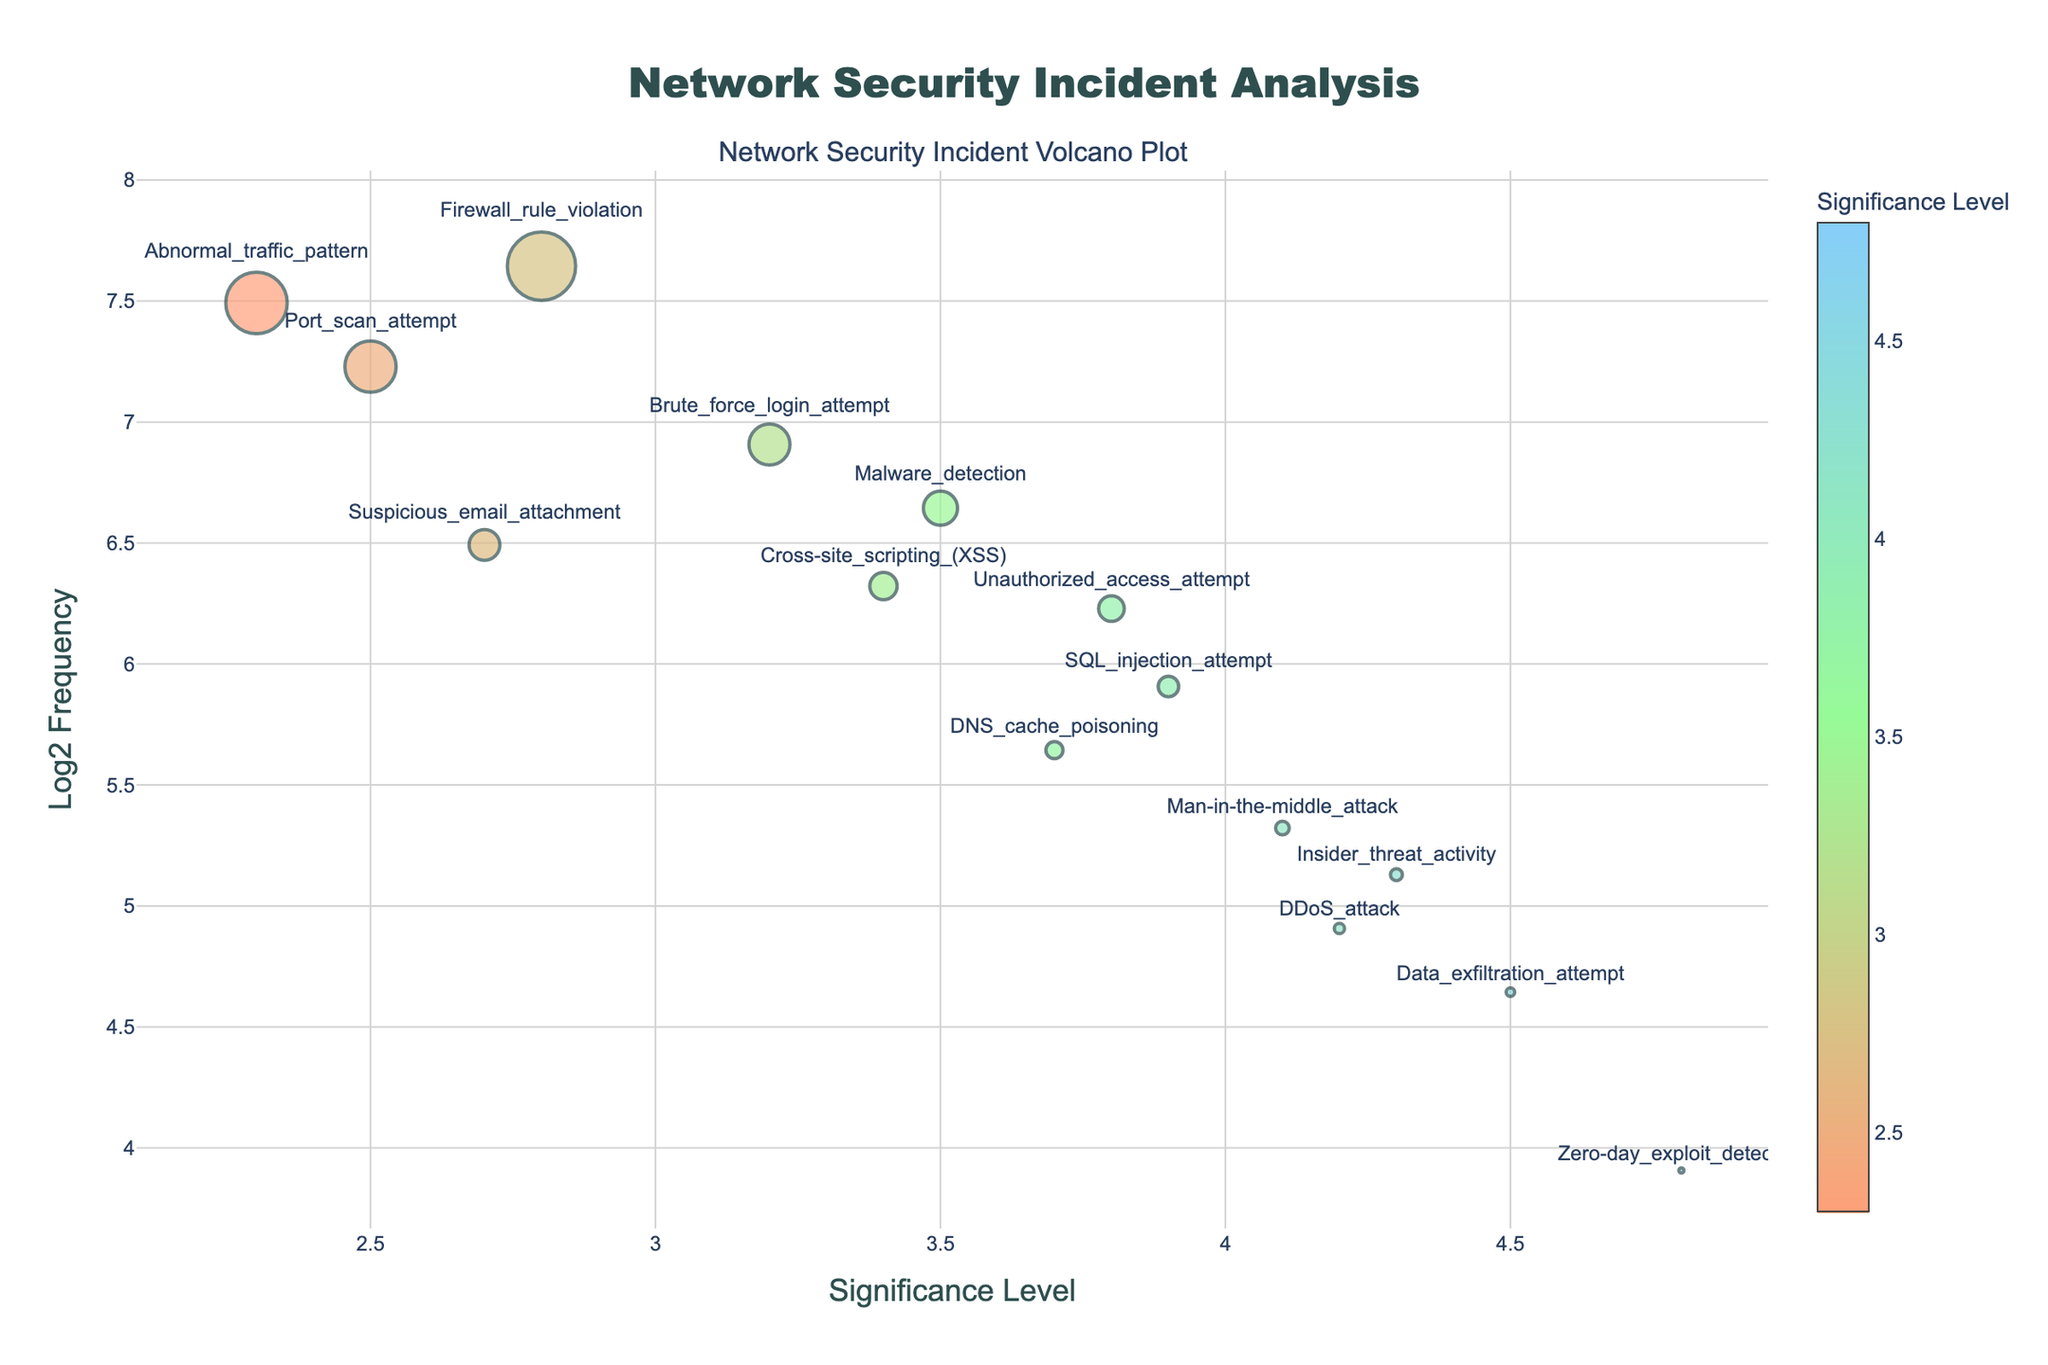what is the title of the plot? The title is the text at the very top of the figure that usually describes what the figure is about. Looking at the figure, the title reads "Network Security Incident Analysis".
Answer: Network Security Incident Analysis what is the y-axis representing? The y-axis title is usually positioned alongside the vertical axis and describes what is being measured. In the figure, the y-axis title is "Log2 Frequency".
Answer: Log2 Frequency Which event has the highest significance level? To find the event with the highest significance level, look for the highest point on the x-axis. The event corresponding to this point in the figure is labeled "Zero-day_exploit_detection".
Answer: Zero-day_exploit_detection How many incidents have a significance level above 4? We look for all data points located to the right of the x-axis value of 4. Those data points are "DDoS_attack", "Data_exfiltration_attempt", "Zero-day_exploit_detection", "Insider_threat_activity", and "Unauthorized_access_attempt". Counting these incidents gives us five.
Answer: 5 Which incident has the highest frequency? To find the incident with the highest frequency, look for the largest marker (since marker size is proportional to frequency) in the figure. The largest marker is labeled "Firewall_rule_violation".
Answer: Firewall_rule_violation Which incidents fall below the y-axis value of 6 on the log2_frequency scale? The y-axis measures log2 frequency, so find all data points with a y-axis value below 6. These incidents are "Port_scan_attempt", "Abnormal_traffic_pattern", "Suspicious_email_attachment", and "Unauthorized_access_attempt".
Answer: Port_scan_attempt, Abnormal_traffic_pattern, Suspicious_email_attachment, Unauthorized_access_attempt What is the relationship between the significance level and log2 frequency of "SQL_injection_attempt"? Find "SQL_injection_attempt" in the figure. Its significance level on the x-axis is around 3.9, and its log2 frequency on the y-axis is around 5.91 (since log2(60) ≈ 5.91).
Answer: Significance level: 3.9, Log2 frequency: 5.91 Which event is close to the significance level of 4 and has a log2 frequency around 5? Look for a data point near x=4 and y=5 on the figure. The closest event is "DDoS_attack" with a significance level of 4.2 and a log2 frequency of 5 (since log2(30) ≈ 5).
Answer: DDoS_attack Is there a general trend between significance level and frequency? By observing the overall distribution of data points in the figure, we can see if there is a positive or negative relationship between the x-axis and y-axis values. The figure shows that higher significance levels often correspond to lower log2 frequency, suggesting a negative trend.
Answer: Negative trend 